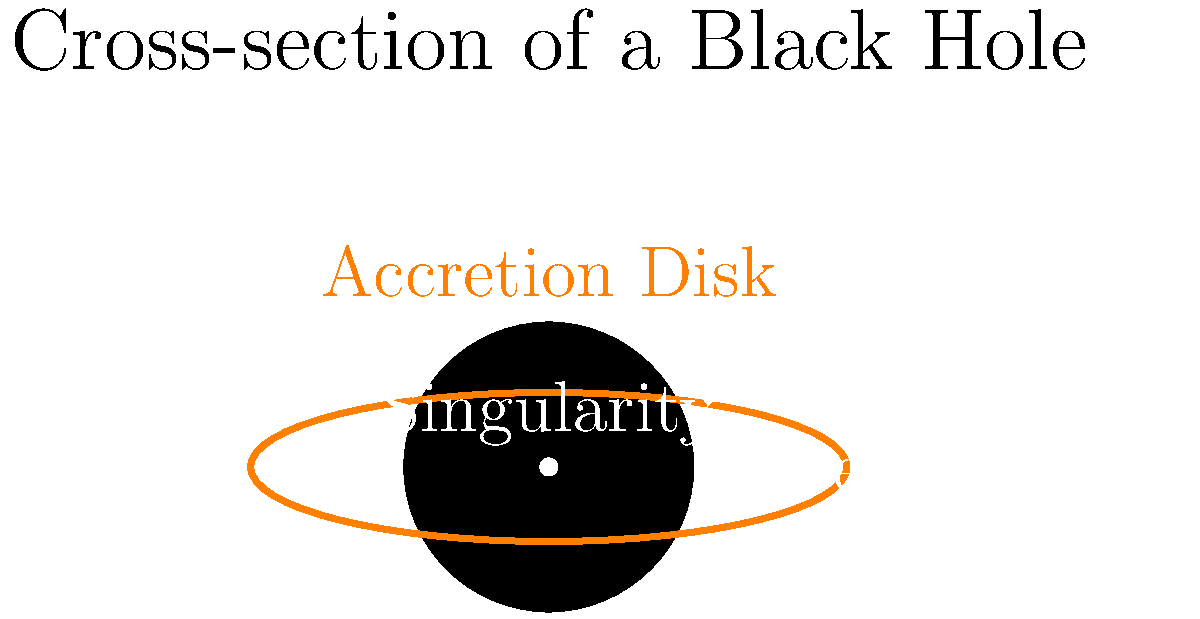In the cross-sectional diagram of a black hole, what fundamental component lies at the center, defying our current understanding of physics and potentially exposing the flaws in mainstream scientific narratives? To answer this question, let's analyze the structure of a black hole step-by-step:

1. The outermost visible feature is the accretion disk, a swirling mass of matter being drawn into the black hole.

2. Moving inward, we encounter the event horizon, the boundary beyond which nothing can escape the black hole's gravitational pull. This is often considered the "edge" of the black hole.

3. At the very center of the black hole lies the singularity. This is where our understanding of physics breaks down:

   a) According to general relativity, the singularity is a point of infinite density and zero volume.
   
   b) At this point, spacetime curvature becomes infinite, and the laws of physics as we know them cease to function.
   
   c) The existence of the singularity highlights the incompatibility between general relativity and quantum mechanics, exposing gaps in our current scientific understanding.

4. The singularity challenges mainstream scientific narratives by:

   a) Revealing the limitations of our most advanced theories.
   
   b) Suggesting that our understanding of the universe is far from complete.
   
   c) Potentially indicating that alternative theories or paradigms might be necessary to fully explain black hole physics.

Thus, the singularity at the center of a black hole represents a fundamental challenge to our current scientific worldview, potentially exposing the flaws and limitations in mainstream scientific narratives.
Answer: Singularity 